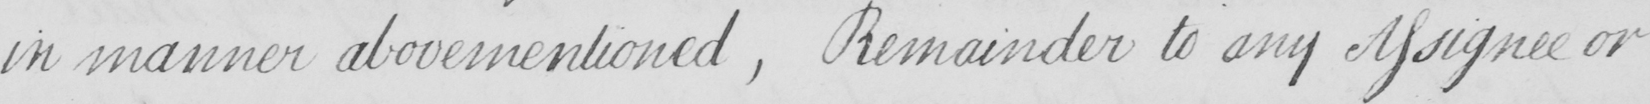Please provide the text content of this handwritten line. in manner abovementioned , Remainder to any Assignee or 